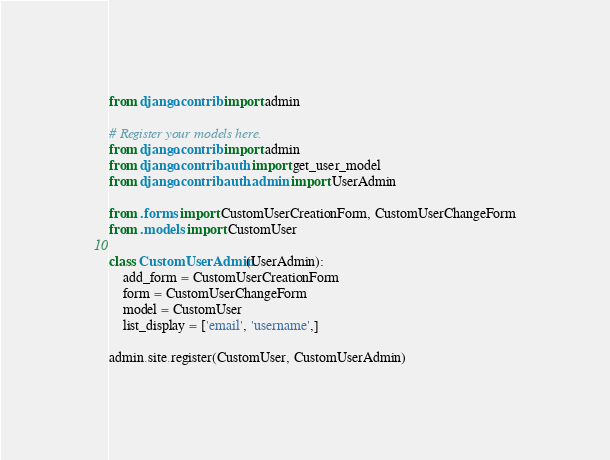Convert code to text. <code><loc_0><loc_0><loc_500><loc_500><_Python_>from django.contrib import admin

# Register your models here.
from django.contrib import admin
from django.contrib.auth import get_user_model
from django.contrib.auth.admin import UserAdmin

from .forms import CustomUserCreationForm, CustomUserChangeForm
from .models import CustomUser

class CustomUserAdmin(UserAdmin):
    add_form = CustomUserCreationForm
    form = CustomUserChangeForm
    model = CustomUser
    list_display = ['email', 'username',]

admin.site.register(CustomUser, CustomUserAdmin)</code> 